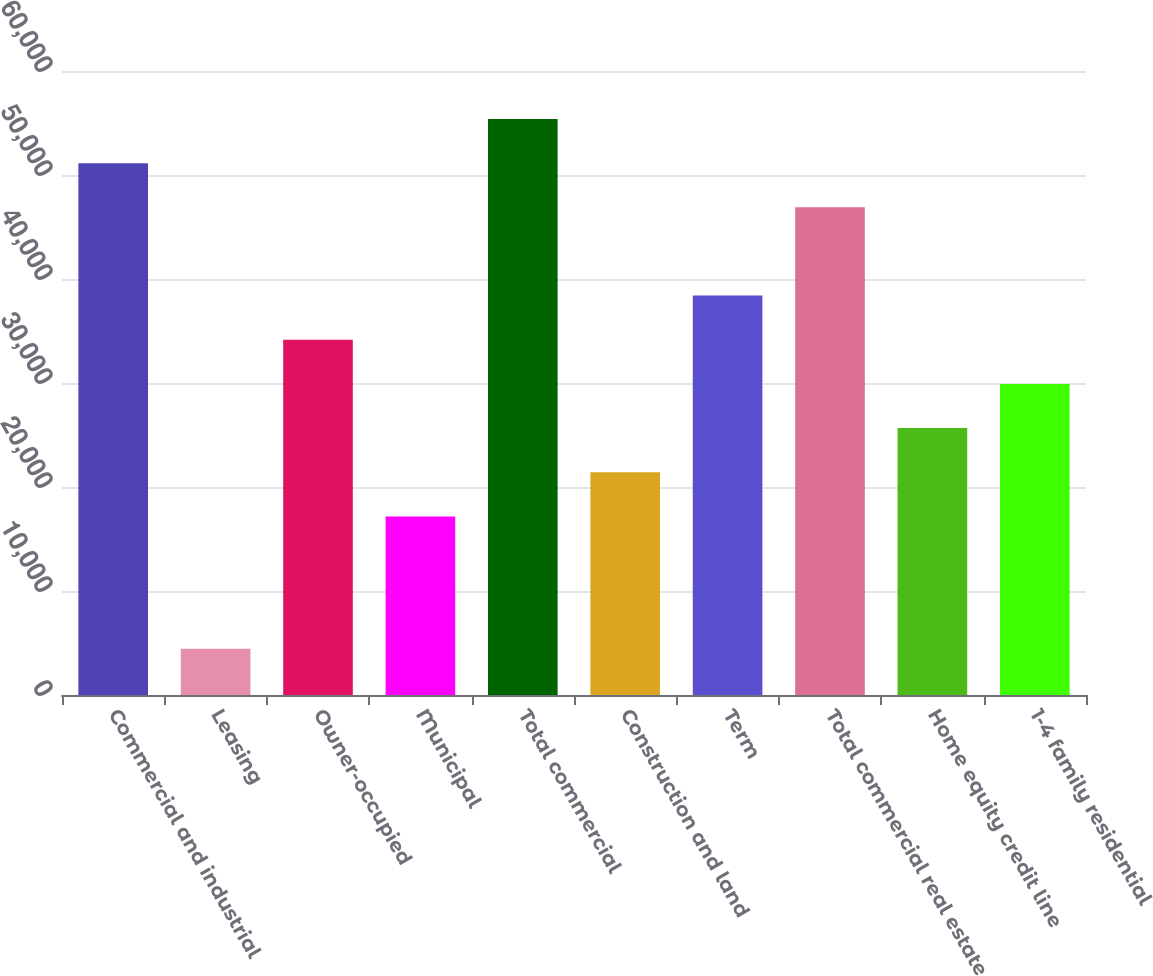Convert chart to OTSL. <chart><loc_0><loc_0><loc_500><loc_500><bar_chart><fcel>Commercial and industrial<fcel>Leasing<fcel>Owner-occupied<fcel>Municipal<fcel>Total commercial<fcel>Construction and land<fcel>Term<fcel>Total commercial real estate<fcel>Home equity credit line<fcel>1-4 family residential<nl><fcel>51140.8<fcel>4435.9<fcel>34157.2<fcel>17173.6<fcel>55386.7<fcel>21419.5<fcel>38403.1<fcel>46894.9<fcel>25665.4<fcel>29911.3<nl></chart> 